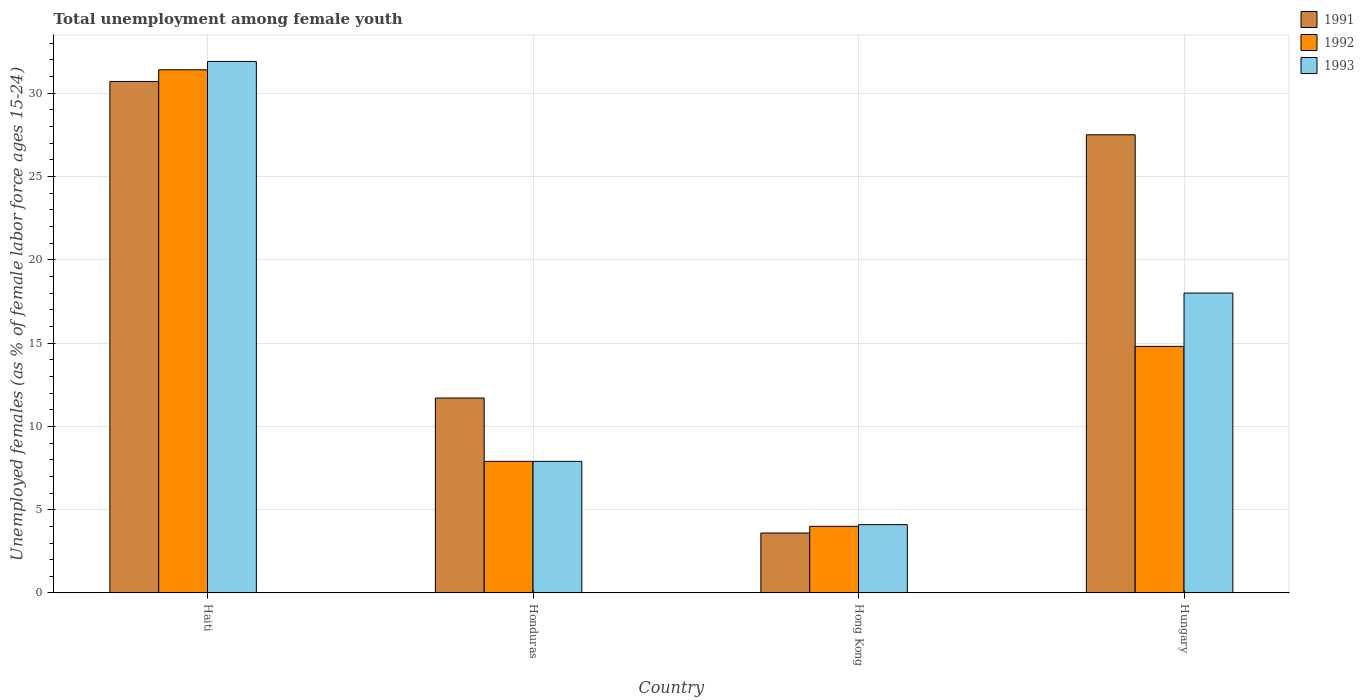How many groups of bars are there?
Keep it short and to the point. 4. Are the number of bars per tick equal to the number of legend labels?
Offer a very short reply. Yes. How many bars are there on the 2nd tick from the left?
Provide a succinct answer. 3. What is the label of the 3rd group of bars from the left?
Your answer should be compact. Hong Kong. In how many cases, is the number of bars for a given country not equal to the number of legend labels?
Give a very brief answer. 0. What is the percentage of unemployed females in in 1993 in Hungary?
Your answer should be compact. 18. Across all countries, what is the maximum percentage of unemployed females in in 1991?
Your response must be concise. 30.7. In which country was the percentage of unemployed females in in 1991 maximum?
Give a very brief answer. Haiti. In which country was the percentage of unemployed females in in 1991 minimum?
Give a very brief answer. Hong Kong. What is the total percentage of unemployed females in in 1993 in the graph?
Give a very brief answer. 61.9. What is the difference between the percentage of unemployed females in in 1993 in Haiti and that in Hungary?
Your answer should be compact. 13.9. What is the difference between the percentage of unemployed females in in 1991 in Hong Kong and the percentage of unemployed females in in 1992 in Honduras?
Your answer should be very brief. -4.3. What is the average percentage of unemployed females in in 1992 per country?
Offer a terse response. 14.52. What is the difference between the percentage of unemployed females in of/in 1993 and percentage of unemployed females in of/in 1992 in Haiti?
Make the answer very short. 0.5. In how many countries, is the percentage of unemployed females in in 1993 greater than 25 %?
Provide a succinct answer. 1. What is the ratio of the percentage of unemployed females in in 1991 in Honduras to that in Hong Kong?
Your response must be concise. 3.25. What is the difference between the highest and the second highest percentage of unemployed females in in 1992?
Make the answer very short. -6.9. What is the difference between the highest and the lowest percentage of unemployed females in in 1992?
Provide a succinct answer. 27.4. What does the 2nd bar from the left in Hungary represents?
Your answer should be compact. 1992. What does the 3rd bar from the right in Hong Kong represents?
Keep it short and to the point. 1991. Are all the bars in the graph horizontal?
Offer a very short reply. No. How many countries are there in the graph?
Your answer should be very brief. 4. What is the difference between two consecutive major ticks on the Y-axis?
Your response must be concise. 5. Are the values on the major ticks of Y-axis written in scientific E-notation?
Your response must be concise. No. Does the graph contain any zero values?
Give a very brief answer. No. Does the graph contain grids?
Your response must be concise. Yes. Where does the legend appear in the graph?
Provide a succinct answer. Top right. What is the title of the graph?
Provide a succinct answer. Total unemployment among female youth. Does "2008" appear as one of the legend labels in the graph?
Offer a very short reply. No. What is the label or title of the Y-axis?
Your answer should be compact. Unemployed females (as % of female labor force ages 15-24). What is the Unemployed females (as % of female labor force ages 15-24) in 1991 in Haiti?
Your response must be concise. 30.7. What is the Unemployed females (as % of female labor force ages 15-24) of 1992 in Haiti?
Keep it short and to the point. 31.4. What is the Unemployed females (as % of female labor force ages 15-24) in 1993 in Haiti?
Provide a short and direct response. 31.9. What is the Unemployed females (as % of female labor force ages 15-24) in 1991 in Honduras?
Offer a very short reply. 11.7. What is the Unemployed females (as % of female labor force ages 15-24) in 1992 in Honduras?
Provide a short and direct response. 7.9. What is the Unemployed females (as % of female labor force ages 15-24) of 1993 in Honduras?
Your answer should be compact. 7.9. What is the Unemployed females (as % of female labor force ages 15-24) of 1991 in Hong Kong?
Offer a terse response. 3.6. What is the Unemployed females (as % of female labor force ages 15-24) in 1992 in Hong Kong?
Your answer should be very brief. 4. What is the Unemployed females (as % of female labor force ages 15-24) of 1993 in Hong Kong?
Your answer should be compact. 4.1. What is the Unemployed females (as % of female labor force ages 15-24) in 1992 in Hungary?
Keep it short and to the point. 14.8. Across all countries, what is the maximum Unemployed females (as % of female labor force ages 15-24) of 1991?
Provide a succinct answer. 30.7. Across all countries, what is the maximum Unemployed females (as % of female labor force ages 15-24) of 1992?
Your answer should be very brief. 31.4. Across all countries, what is the maximum Unemployed females (as % of female labor force ages 15-24) in 1993?
Provide a short and direct response. 31.9. Across all countries, what is the minimum Unemployed females (as % of female labor force ages 15-24) in 1991?
Ensure brevity in your answer.  3.6. Across all countries, what is the minimum Unemployed females (as % of female labor force ages 15-24) of 1993?
Give a very brief answer. 4.1. What is the total Unemployed females (as % of female labor force ages 15-24) of 1991 in the graph?
Your answer should be compact. 73.5. What is the total Unemployed females (as % of female labor force ages 15-24) in 1992 in the graph?
Make the answer very short. 58.1. What is the total Unemployed females (as % of female labor force ages 15-24) of 1993 in the graph?
Your answer should be compact. 61.9. What is the difference between the Unemployed females (as % of female labor force ages 15-24) of 1992 in Haiti and that in Honduras?
Provide a short and direct response. 23.5. What is the difference between the Unemployed females (as % of female labor force ages 15-24) in 1991 in Haiti and that in Hong Kong?
Your answer should be very brief. 27.1. What is the difference between the Unemployed females (as % of female labor force ages 15-24) of 1992 in Haiti and that in Hong Kong?
Your answer should be compact. 27.4. What is the difference between the Unemployed females (as % of female labor force ages 15-24) of 1993 in Haiti and that in Hong Kong?
Your answer should be compact. 27.8. What is the difference between the Unemployed females (as % of female labor force ages 15-24) of 1991 in Haiti and that in Hungary?
Offer a very short reply. 3.2. What is the difference between the Unemployed females (as % of female labor force ages 15-24) in 1992 in Haiti and that in Hungary?
Your answer should be compact. 16.6. What is the difference between the Unemployed females (as % of female labor force ages 15-24) of 1991 in Honduras and that in Hong Kong?
Provide a short and direct response. 8.1. What is the difference between the Unemployed females (as % of female labor force ages 15-24) of 1992 in Honduras and that in Hong Kong?
Provide a succinct answer. 3.9. What is the difference between the Unemployed females (as % of female labor force ages 15-24) of 1991 in Honduras and that in Hungary?
Your answer should be very brief. -15.8. What is the difference between the Unemployed females (as % of female labor force ages 15-24) of 1992 in Honduras and that in Hungary?
Give a very brief answer. -6.9. What is the difference between the Unemployed females (as % of female labor force ages 15-24) in 1993 in Honduras and that in Hungary?
Your answer should be very brief. -10.1. What is the difference between the Unemployed females (as % of female labor force ages 15-24) in 1991 in Hong Kong and that in Hungary?
Provide a succinct answer. -23.9. What is the difference between the Unemployed females (as % of female labor force ages 15-24) in 1992 in Hong Kong and that in Hungary?
Provide a short and direct response. -10.8. What is the difference between the Unemployed females (as % of female labor force ages 15-24) of 1993 in Hong Kong and that in Hungary?
Offer a very short reply. -13.9. What is the difference between the Unemployed females (as % of female labor force ages 15-24) in 1991 in Haiti and the Unemployed females (as % of female labor force ages 15-24) in 1992 in Honduras?
Make the answer very short. 22.8. What is the difference between the Unemployed females (as % of female labor force ages 15-24) of 1991 in Haiti and the Unemployed females (as % of female labor force ages 15-24) of 1993 in Honduras?
Offer a very short reply. 22.8. What is the difference between the Unemployed females (as % of female labor force ages 15-24) in 1991 in Haiti and the Unemployed females (as % of female labor force ages 15-24) in 1992 in Hong Kong?
Ensure brevity in your answer.  26.7. What is the difference between the Unemployed females (as % of female labor force ages 15-24) of 1991 in Haiti and the Unemployed females (as % of female labor force ages 15-24) of 1993 in Hong Kong?
Your answer should be very brief. 26.6. What is the difference between the Unemployed females (as % of female labor force ages 15-24) in 1992 in Haiti and the Unemployed females (as % of female labor force ages 15-24) in 1993 in Hong Kong?
Make the answer very short. 27.3. What is the difference between the Unemployed females (as % of female labor force ages 15-24) of 1991 in Haiti and the Unemployed females (as % of female labor force ages 15-24) of 1992 in Hungary?
Make the answer very short. 15.9. What is the difference between the Unemployed females (as % of female labor force ages 15-24) of 1991 in Haiti and the Unemployed females (as % of female labor force ages 15-24) of 1993 in Hungary?
Your answer should be very brief. 12.7. What is the difference between the Unemployed females (as % of female labor force ages 15-24) in 1992 in Haiti and the Unemployed females (as % of female labor force ages 15-24) in 1993 in Hungary?
Give a very brief answer. 13.4. What is the difference between the Unemployed females (as % of female labor force ages 15-24) in 1991 in Honduras and the Unemployed females (as % of female labor force ages 15-24) in 1992 in Hong Kong?
Your answer should be very brief. 7.7. What is the difference between the Unemployed females (as % of female labor force ages 15-24) in 1992 in Honduras and the Unemployed females (as % of female labor force ages 15-24) in 1993 in Hong Kong?
Ensure brevity in your answer.  3.8. What is the difference between the Unemployed females (as % of female labor force ages 15-24) in 1991 in Honduras and the Unemployed females (as % of female labor force ages 15-24) in 1992 in Hungary?
Your response must be concise. -3.1. What is the difference between the Unemployed females (as % of female labor force ages 15-24) of 1991 in Honduras and the Unemployed females (as % of female labor force ages 15-24) of 1993 in Hungary?
Offer a terse response. -6.3. What is the difference between the Unemployed females (as % of female labor force ages 15-24) of 1991 in Hong Kong and the Unemployed females (as % of female labor force ages 15-24) of 1992 in Hungary?
Your answer should be compact. -11.2. What is the difference between the Unemployed females (as % of female labor force ages 15-24) in 1991 in Hong Kong and the Unemployed females (as % of female labor force ages 15-24) in 1993 in Hungary?
Provide a short and direct response. -14.4. What is the difference between the Unemployed females (as % of female labor force ages 15-24) in 1992 in Hong Kong and the Unemployed females (as % of female labor force ages 15-24) in 1993 in Hungary?
Ensure brevity in your answer.  -14. What is the average Unemployed females (as % of female labor force ages 15-24) of 1991 per country?
Your answer should be compact. 18.38. What is the average Unemployed females (as % of female labor force ages 15-24) in 1992 per country?
Ensure brevity in your answer.  14.53. What is the average Unemployed females (as % of female labor force ages 15-24) in 1993 per country?
Your answer should be compact. 15.47. What is the difference between the Unemployed females (as % of female labor force ages 15-24) in 1991 and Unemployed females (as % of female labor force ages 15-24) in 1993 in Haiti?
Provide a short and direct response. -1.2. What is the difference between the Unemployed females (as % of female labor force ages 15-24) in 1991 and Unemployed females (as % of female labor force ages 15-24) in 1992 in Honduras?
Your answer should be compact. 3.8. What is the difference between the Unemployed females (as % of female labor force ages 15-24) in 1991 and Unemployed females (as % of female labor force ages 15-24) in 1992 in Hong Kong?
Offer a terse response. -0.4. What is the difference between the Unemployed females (as % of female labor force ages 15-24) of 1992 and Unemployed females (as % of female labor force ages 15-24) of 1993 in Hong Kong?
Keep it short and to the point. -0.1. What is the difference between the Unemployed females (as % of female labor force ages 15-24) of 1991 and Unemployed females (as % of female labor force ages 15-24) of 1992 in Hungary?
Ensure brevity in your answer.  12.7. What is the difference between the Unemployed females (as % of female labor force ages 15-24) of 1992 and Unemployed females (as % of female labor force ages 15-24) of 1993 in Hungary?
Give a very brief answer. -3.2. What is the ratio of the Unemployed females (as % of female labor force ages 15-24) in 1991 in Haiti to that in Honduras?
Offer a very short reply. 2.62. What is the ratio of the Unemployed females (as % of female labor force ages 15-24) of 1992 in Haiti to that in Honduras?
Your answer should be very brief. 3.97. What is the ratio of the Unemployed females (as % of female labor force ages 15-24) in 1993 in Haiti to that in Honduras?
Offer a very short reply. 4.04. What is the ratio of the Unemployed females (as % of female labor force ages 15-24) of 1991 in Haiti to that in Hong Kong?
Offer a very short reply. 8.53. What is the ratio of the Unemployed females (as % of female labor force ages 15-24) of 1992 in Haiti to that in Hong Kong?
Offer a very short reply. 7.85. What is the ratio of the Unemployed females (as % of female labor force ages 15-24) in 1993 in Haiti to that in Hong Kong?
Provide a succinct answer. 7.78. What is the ratio of the Unemployed females (as % of female labor force ages 15-24) in 1991 in Haiti to that in Hungary?
Provide a short and direct response. 1.12. What is the ratio of the Unemployed females (as % of female labor force ages 15-24) of 1992 in Haiti to that in Hungary?
Provide a short and direct response. 2.12. What is the ratio of the Unemployed females (as % of female labor force ages 15-24) in 1993 in Haiti to that in Hungary?
Ensure brevity in your answer.  1.77. What is the ratio of the Unemployed females (as % of female labor force ages 15-24) in 1992 in Honduras to that in Hong Kong?
Keep it short and to the point. 1.98. What is the ratio of the Unemployed females (as % of female labor force ages 15-24) in 1993 in Honduras to that in Hong Kong?
Your answer should be compact. 1.93. What is the ratio of the Unemployed females (as % of female labor force ages 15-24) in 1991 in Honduras to that in Hungary?
Make the answer very short. 0.43. What is the ratio of the Unemployed females (as % of female labor force ages 15-24) of 1992 in Honduras to that in Hungary?
Provide a short and direct response. 0.53. What is the ratio of the Unemployed females (as % of female labor force ages 15-24) in 1993 in Honduras to that in Hungary?
Your answer should be compact. 0.44. What is the ratio of the Unemployed females (as % of female labor force ages 15-24) in 1991 in Hong Kong to that in Hungary?
Offer a terse response. 0.13. What is the ratio of the Unemployed females (as % of female labor force ages 15-24) in 1992 in Hong Kong to that in Hungary?
Make the answer very short. 0.27. What is the ratio of the Unemployed females (as % of female labor force ages 15-24) in 1993 in Hong Kong to that in Hungary?
Offer a terse response. 0.23. What is the difference between the highest and the second highest Unemployed females (as % of female labor force ages 15-24) in 1991?
Keep it short and to the point. 3.2. What is the difference between the highest and the second highest Unemployed females (as % of female labor force ages 15-24) of 1993?
Ensure brevity in your answer.  13.9. What is the difference between the highest and the lowest Unemployed females (as % of female labor force ages 15-24) in 1991?
Give a very brief answer. 27.1. What is the difference between the highest and the lowest Unemployed females (as % of female labor force ages 15-24) of 1992?
Make the answer very short. 27.4. What is the difference between the highest and the lowest Unemployed females (as % of female labor force ages 15-24) in 1993?
Ensure brevity in your answer.  27.8. 